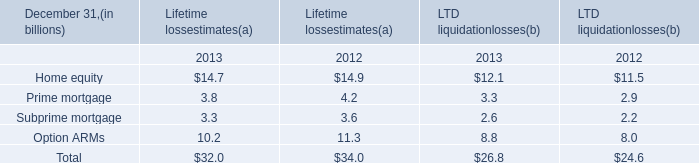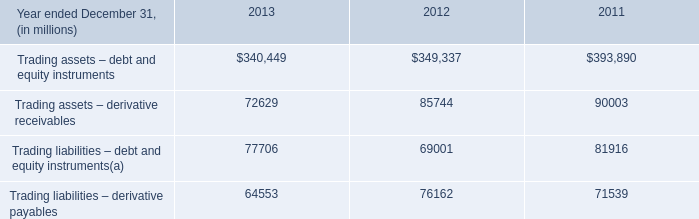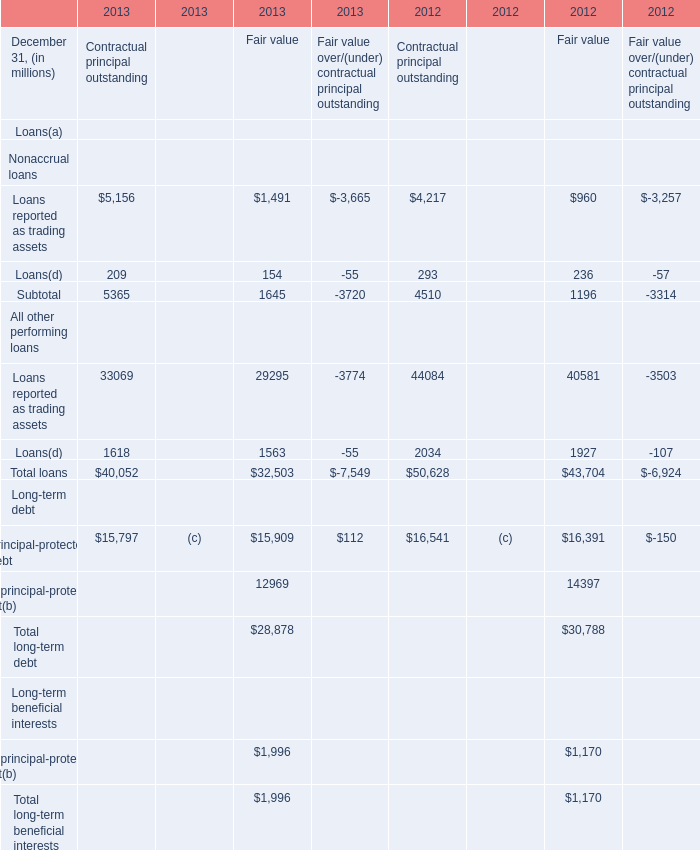What is the total amount of Trading liabilities – debt and equity instruments of 2011, and Loans reported as trading assets of 2013 Contractual principal outstanding ? 
Computations: (81916.0 + 5156.0)
Answer: 87072.0. 